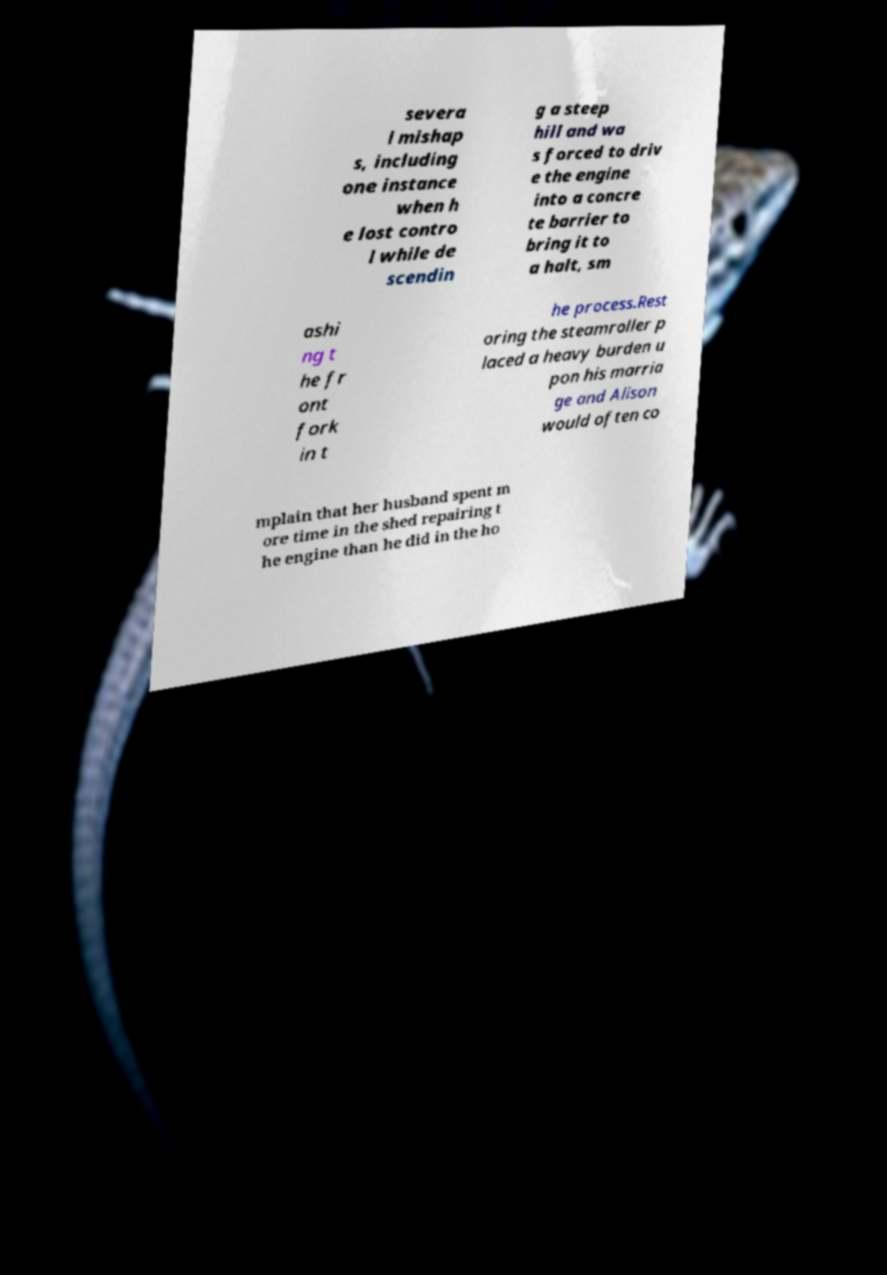There's text embedded in this image that I need extracted. Can you transcribe it verbatim? severa l mishap s, including one instance when h e lost contro l while de scendin g a steep hill and wa s forced to driv e the engine into a concre te barrier to bring it to a halt, sm ashi ng t he fr ont fork in t he process.Rest oring the steamroller p laced a heavy burden u pon his marria ge and Alison would often co mplain that her husband spent m ore time in the shed repairing t he engine than he did in the ho 